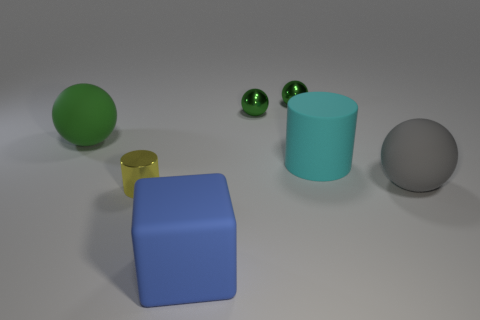Subtract all purple cubes. How many green balls are left? 3 Add 3 cyan metal cubes. How many objects exist? 10 Subtract all cylinders. How many objects are left? 5 Add 3 gray rubber spheres. How many gray rubber spheres exist? 4 Subtract 0 purple cylinders. How many objects are left? 7 Subtract all shiny objects. Subtract all tiny yellow metal objects. How many objects are left? 3 Add 7 small yellow shiny cylinders. How many small yellow shiny cylinders are left? 8 